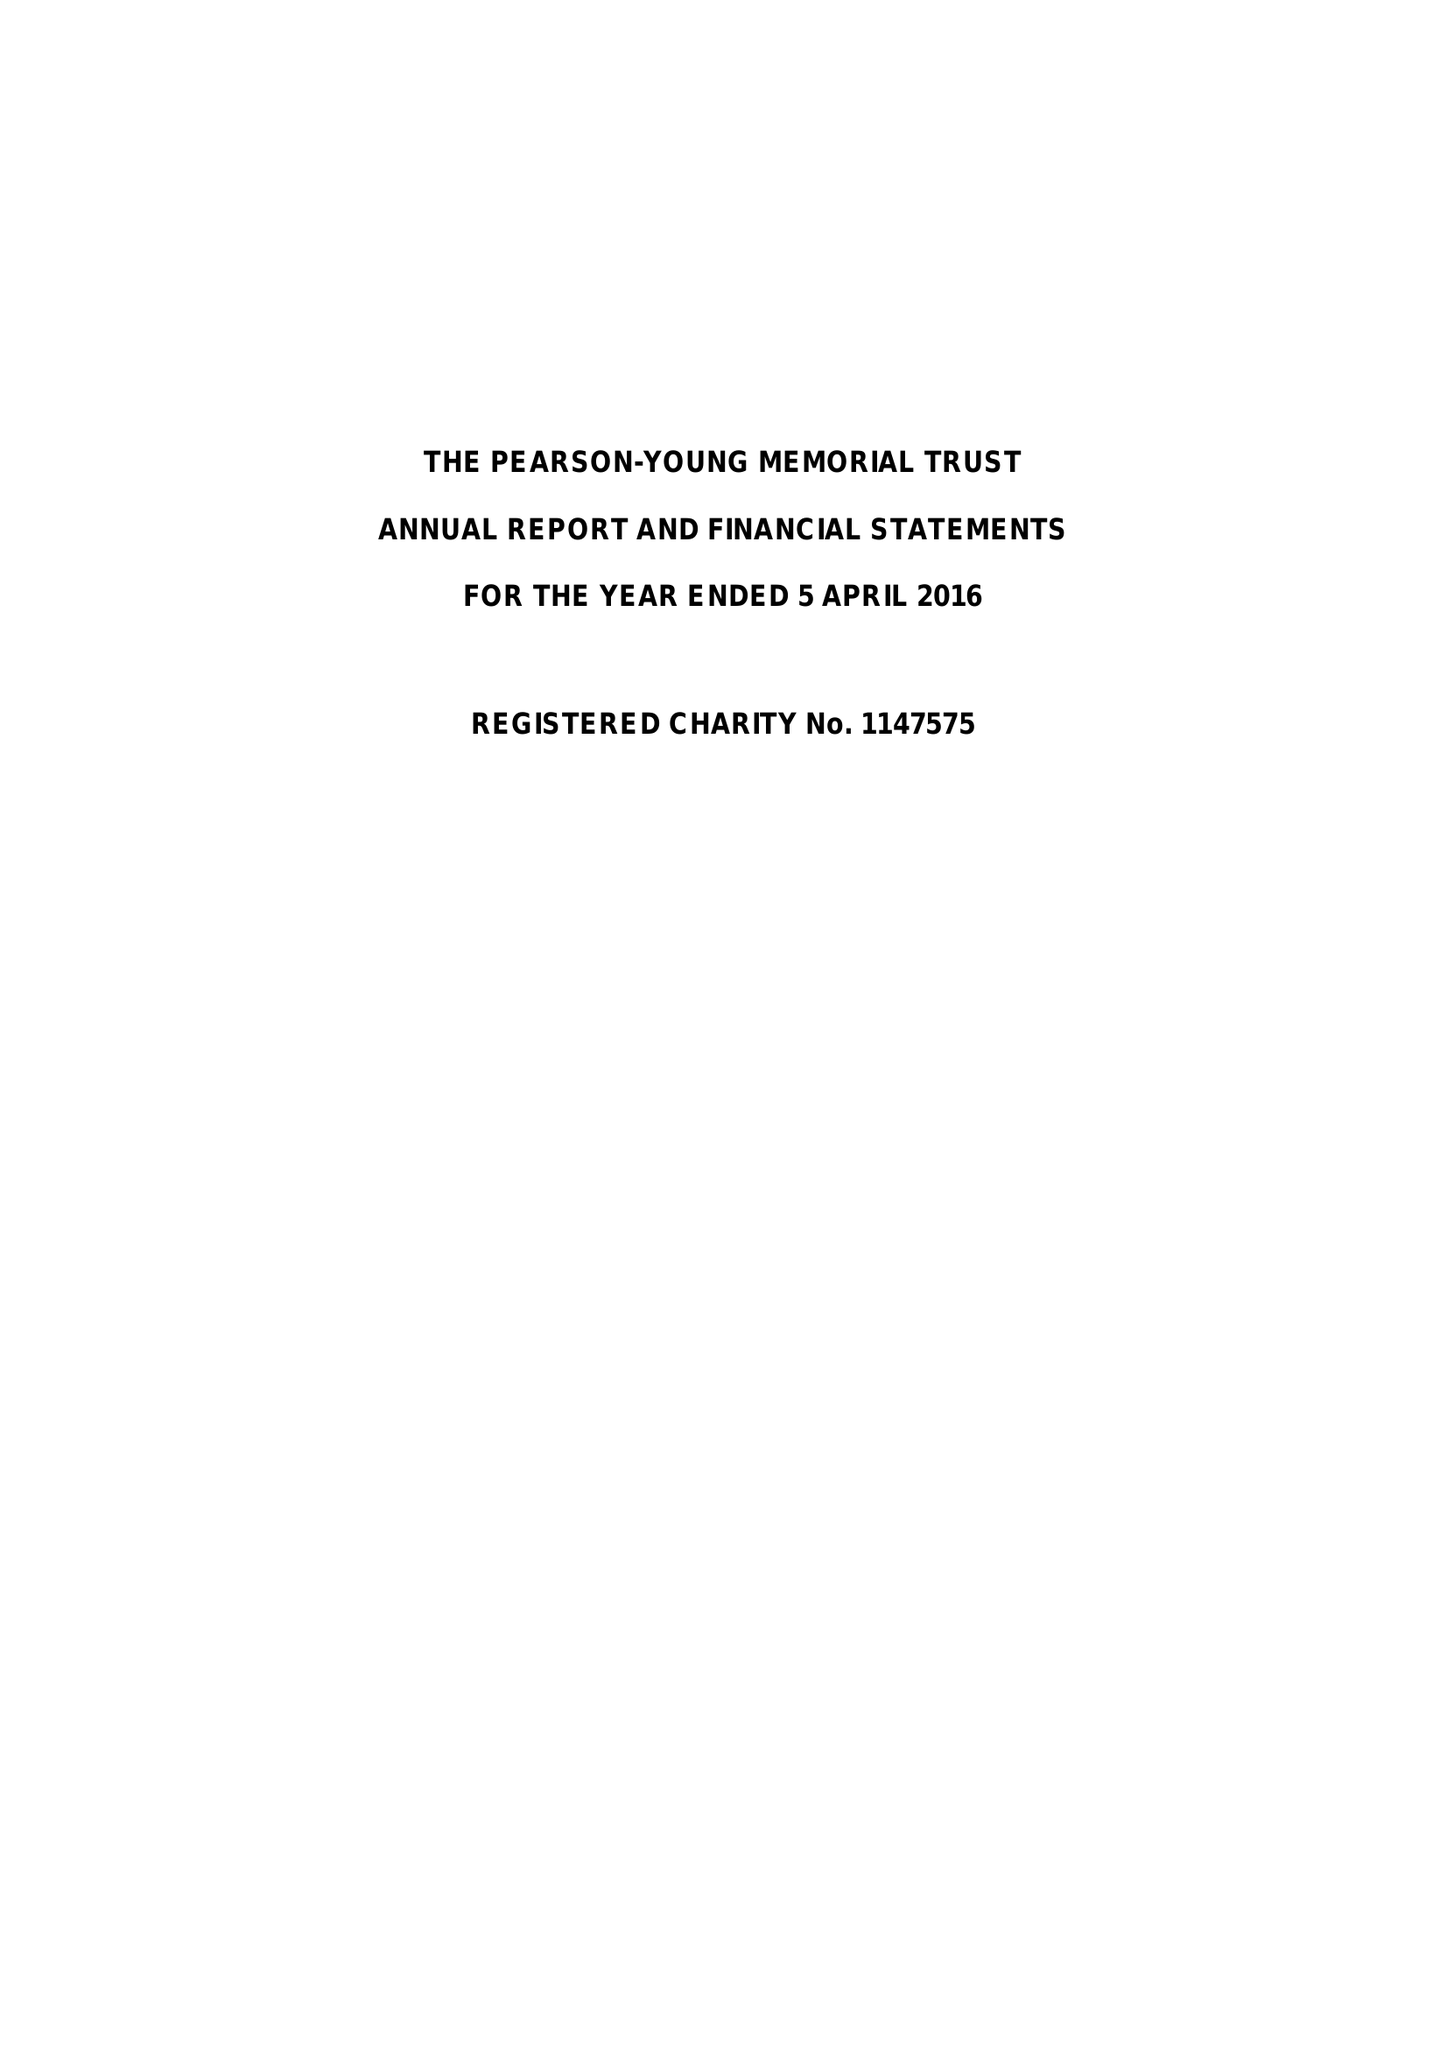What is the value for the charity_number?
Answer the question using a single word or phrase. 1147575 